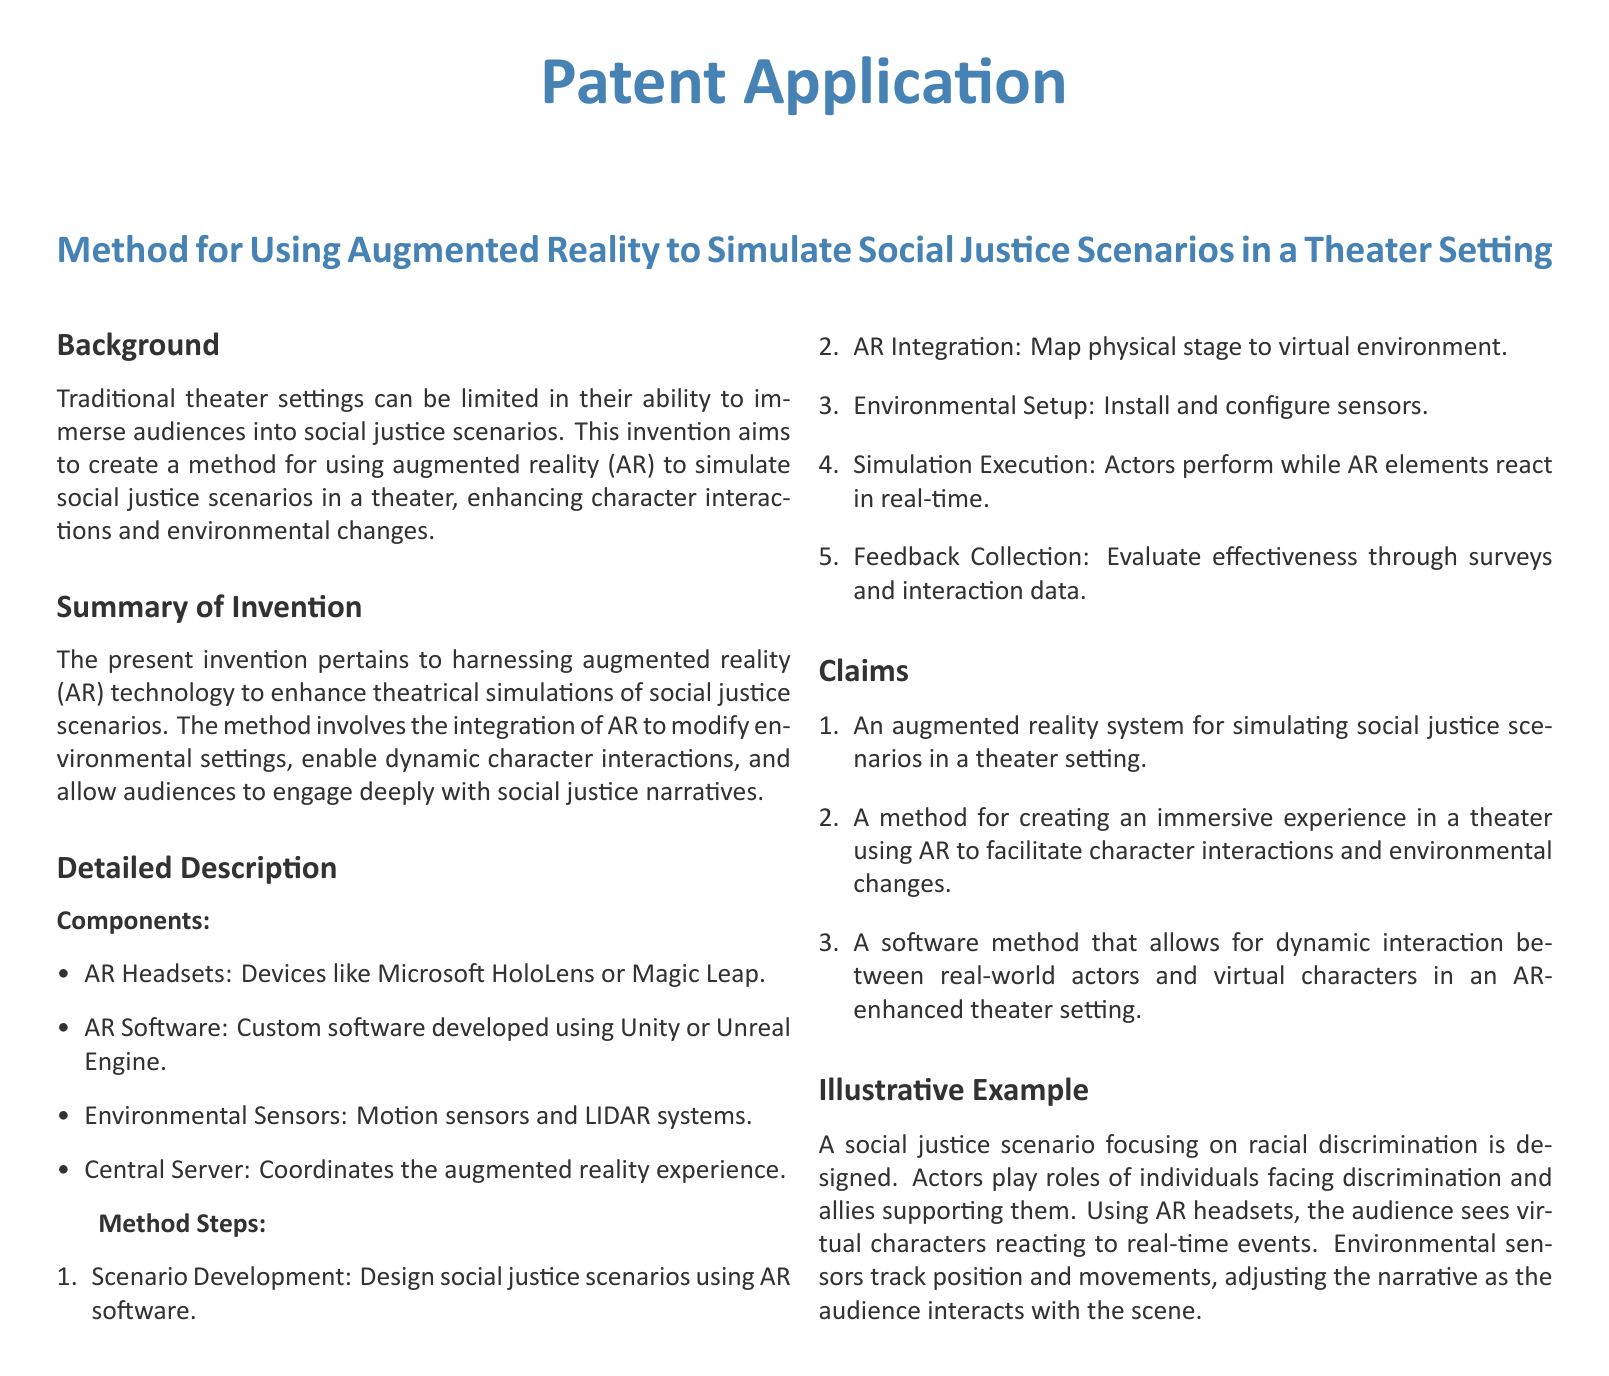What is the main technology used in the invention? The main technology used in the invention is augmented reality (AR).
Answer: augmented reality (AR) What devices are mentioned as AR headsets? The document lists devices like Microsoft HoloLens or Magic Leap as AR headsets.
Answer: Microsoft HoloLens or Magic Leap What is the first step in the method? The first step in the method is scenario development.
Answer: scenario development How many claims are listed in the document? The document includes three claims pertaining to the invention.
Answer: three What software is mentioned for developing AR applications? The software mentioned for developing AR applications includes Unity or Unreal Engine.
Answer: Unity or Unreal Engine What example scenario does the document illustrate? The illustrative example focuses on a social justice scenario involving racial discrimination.
Answer: racial discrimination What do environmental sensors do in this invention? Environmental sensors track position and movements during the simulation.
Answer: track position and movements What is the purpose of AR integration in the method? The purpose of AR integration is to map the physical stage to a virtual environment.
Answer: map physical stage to virtual environment What type of feedback is collected in the method? The method collects effectiveness feedback through surveys and interaction data.
Answer: surveys and interaction data 